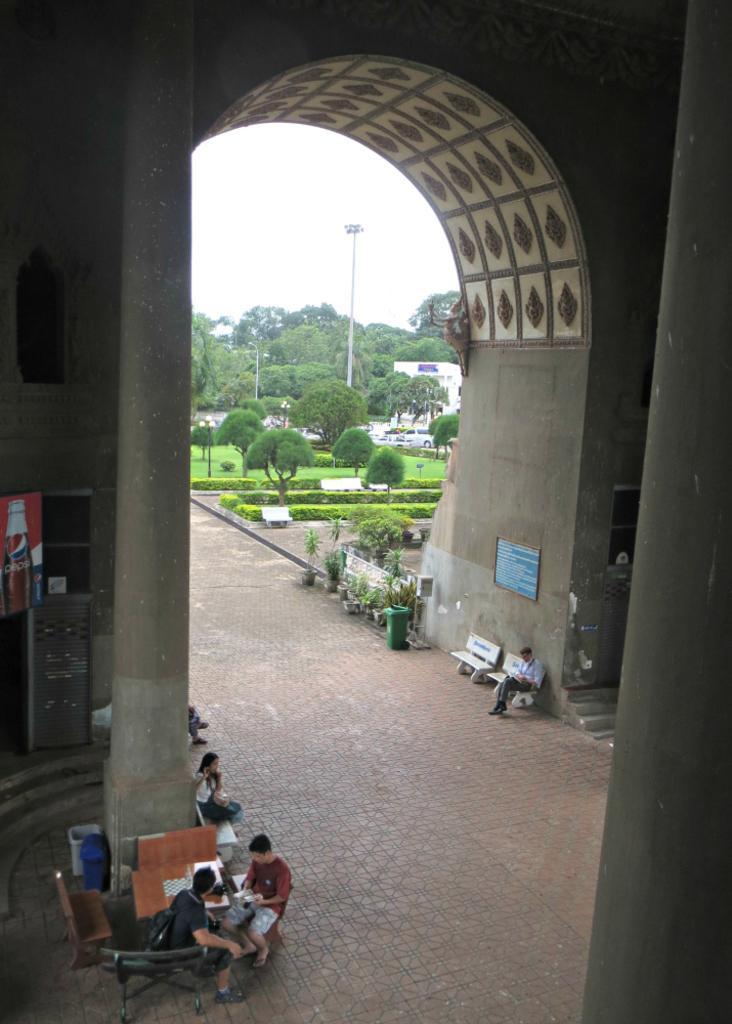In one or two sentences, can you explain what this image depicts? In this image I can see a person sitting on bench in the middle ,beside the person I can see another bench and green color container and flower pots and plants and in the middle I can see grass, bushes and trees and the sky and pole visible , on the left side I can see a beam in front of beam I can see chairs and table, on it I can see persons, I can see a hoarding board and two containers visible back side of the beam , on the right side I can see another beam , I can see the wall visible at the top 